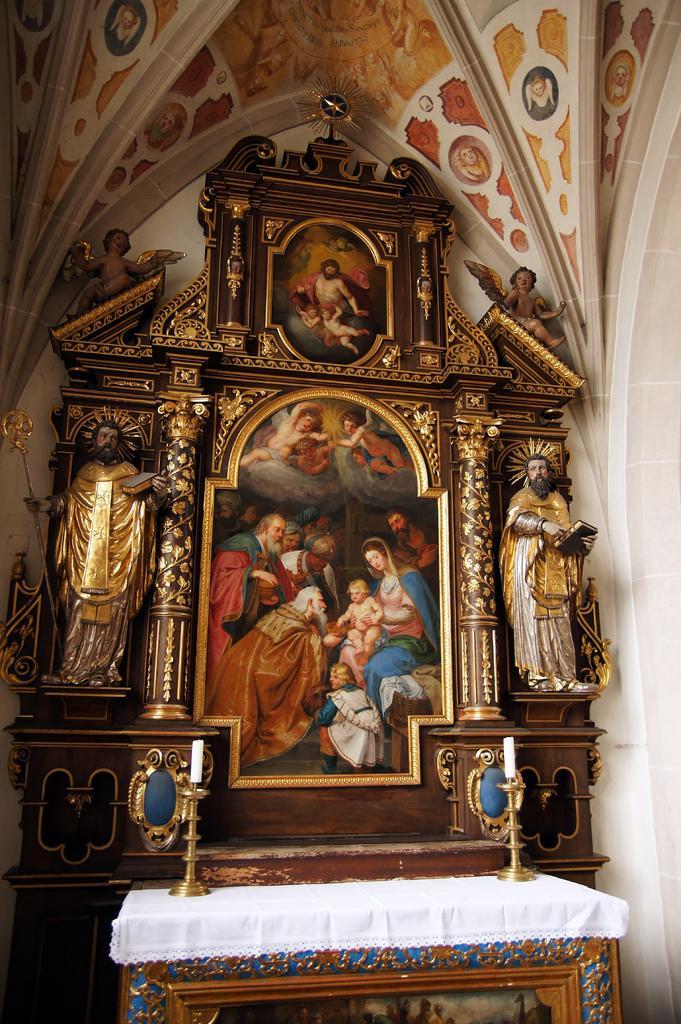Please provide a concise description of this image. This image consists of a photo frame. In the front, we can see a table on which there are candle stands. And it is covered with a white cloth. In the background, we can see a wall. On the left and right, there are idols. At the top, there is a roof. 